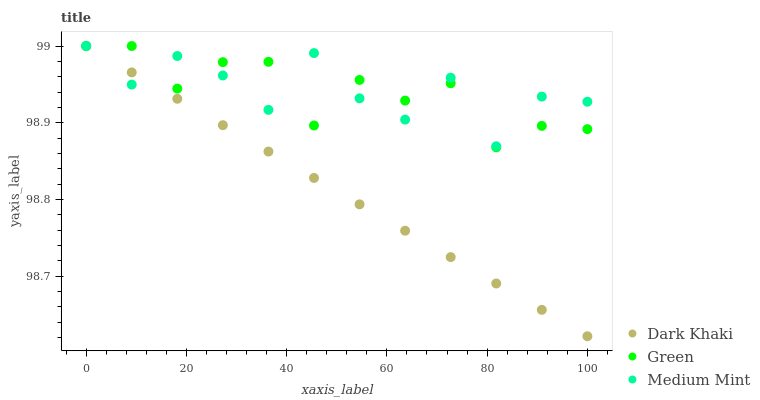Does Dark Khaki have the minimum area under the curve?
Answer yes or no. Yes. Does Medium Mint have the maximum area under the curve?
Answer yes or no. Yes. Does Green have the minimum area under the curve?
Answer yes or no. No. Does Green have the maximum area under the curve?
Answer yes or no. No. Is Dark Khaki the smoothest?
Answer yes or no. Yes. Is Medium Mint the roughest?
Answer yes or no. Yes. Is Green the smoothest?
Answer yes or no. No. Is Green the roughest?
Answer yes or no. No. Does Dark Khaki have the lowest value?
Answer yes or no. Yes. Does Green have the lowest value?
Answer yes or no. No. Does Green have the highest value?
Answer yes or no. Yes. Does Green intersect Dark Khaki?
Answer yes or no. Yes. Is Green less than Dark Khaki?
Answer yes or no. No. Is Green greater than Dark Khaki?
Answer yes or no. No. 